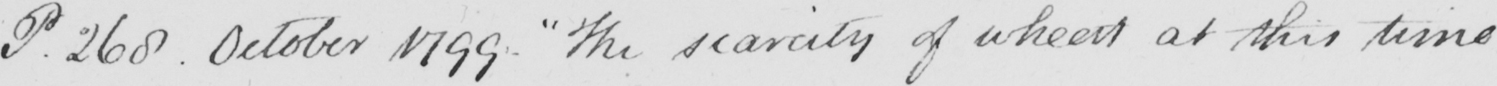Can you tell me what this handwritten text says? P . 268 . October 1799 .  " The scarcity of wheat at this time 